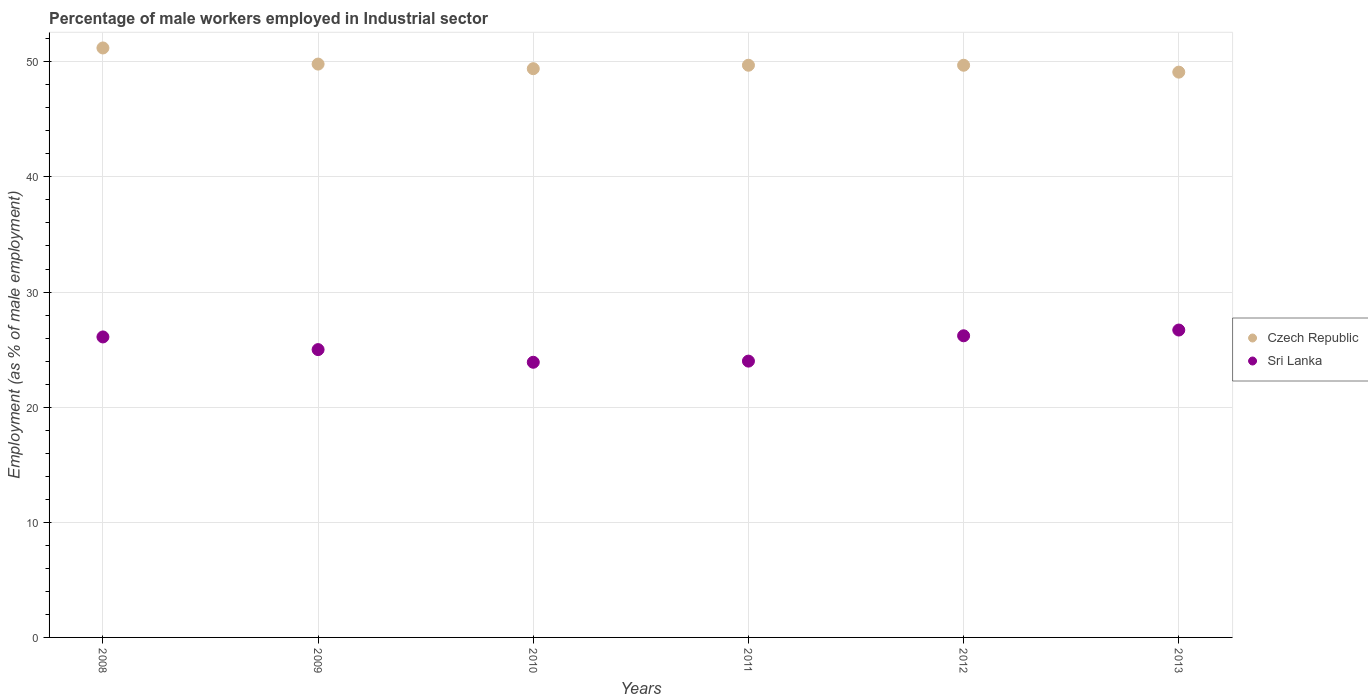What is the percentage of male workers employed in Industrial sector in Czech Republic in 2013?
Provide a short and direct response. 49.1. Across all years, what is the maximum percentage of male workers employed in Industrial sector in Sri Lanka?
Make the answer very short. 26.7. Across all years, what is the minimum percentage of male workers employed in Industrial sector in Czech Republic?
Your answer should be compact. 49.1. In which year was the percentage of male workers employed in Industrial sector in Sri Lanka minimum?
Your answer should be very brief. 2010. What is the total percentage of male workers employed in Industrial sector in Sri Lanka in the graph?
Provide a short and direct response. 151.9. What is the difference between the percentage of male workers employed in Industrial sector in Sri Lanka in 2011 and the percentage of male workers employed in Industrial sector in Czech Republic in 2010?
Your response must be concise. -25.4. What is the average percentage of male workers employed in Industrial sector in Czech Republic per year?
Keep it short and to the point. 49.82. In the year 2012, what is the difference between the percentage of male workers employed in Industrial sector in Sri Lanka and percentage of male workers employed in Industrial sector in Czech Republic?
Keep it short and to the point. -23.5. What is the ratio of the percentage of male workers employed in Industrial sector in Sri Lanka in 2010 to that in 2012?
Provide a succinct answer. 0.91. Is the percentage of male workers employed in Industrial sector in Sri Lanka in 2008 less than that in 2009?
Ensure brevity in your answer.  No. Is the difference between the percentage of male workers employed in Industrial sector in Sri Lanka in 2009 and 2010 greater than the difference between the percentage of male workers employed in Industrial sector in Czech Republic in 2009 and 2010?
Offer a terse response. Yes. What is the difference between the highest and the second highest percentage of male workers employed in Industrial sector in Czech Republic?
Give a very brief answer. 1.4. What is the difference between the highest and the lowest percentage of male workers employed in Industrial sector in Sri Lanka?
Ensure brevity in your answer.  2.8. In how many years, is the percentage of male workers employed in Industrial sector in Czech Republic greater than the average percentage of male workers employed in Industrial sector in Czech Republic taken over all years?
Provide a succinct answer. 1. Is the sum of the percentage of male workers employed in Industrial sector in Czech Republic in 2009 and 2013 greater than the maximum percentage of male workers employed in Industrial sector in Sri Lanka across all years?
Provide a short and direct response. Yes. Does the percentage of male workers employed in Industrial sector in Sri Lanka monotonically increase over the years?
Offer a terse response. No. Is the percentage of male workers employed in Industrial sector in Sri Lanka strictly less than the percentage of male workers employed in Industrial sector in Czech Republic over the years?
Give a very brief answer. Yes. How many dotlines are there?
Keep it short and to the point. 2. How many years are there in the graph?
Offer a very short reply. 6. Are the values on the major ticks of Y-axis written in scientific E-notation?
Make the answer very short. No. Does the graph contain grids?
Provide a short and direct response. Yes. How many legend labels are there?
Your response must be concise. 2. What is the title of the graph?
Provide a succinct answer. Percentage of male workers employed in Industrial sector. Does "Austria" appear as one of the legend labels in the graph?
Provide a succinct answer. No. What is the label or title of the X-axis?
Give a very brief answer. Years. What is the label or title of the Y-axis?
Keep it short and to the point. Employment (as % of male employment). What is the Employment (as % of male employment) of Czech Republic in 2008?
Give a very brief answer. 51.2. What is the Employment (as % of male employment) in Sri Lanka in 2008?
Keep it short and to the point. 26.1. What is the Employment (as % of male employment) of Czech Republic in 2009?
Offer a very short reply. 49.8. What is the Employment (as % of male employment) of Czech Republic in 2010?
Give a very brief answer. 49.4. What is the Employment (as % of male employment) in Sri Lanka in 2010?
Give a very brief answer. 23.9. What is the Employment (as % of male employment) in Czech Republic in 2011?
Your answer should be compact. 49.7. What is the Employment (as % of male employment) of Sri Lanka in 2011?
Give a very brief answer. 24. What is the Employment (as % of male employment) of Czech Republic in 2012?
Provide a succinct answer. 49.7. What is the Employment (as % of male employment) of Sri Lanka in 2012?
Your answer should be very brief. 26.2. What is the Employment (as % of male employment) in Czech Republic in 2013?
Give a very brief answer. 49.1. What is the Employment (as % of male employment) of Sri Lanka in 2013?
Your answer should be very brief. 26.7. Across all years, what is the maximum Employment (as % of male employment) of Czech Republic?
Give a very brief answer. 51.2. Across all years, what is the maximum Employment (as % of male employment) of Sri Lanka?
Provide a short and direct response. 26.7. Across all years, what is the minimum Employment (as % of male employment) in Czech Republic?
Your response must be concise. 49.1. Across all years, what is the minimum Employment (as % of male employment) in Sri Lanka?
Ensure brevity in your answer.  23.9. What is the total Employment (as % of male employment) in Czech Republic in the graph?
Keep it short and to the point. 298.9. What is the total Employment (as % of male employment) in Sri Lanka in the graph?
Keep it short and to the point. 151.9. What is the difference between the Employment (as % of male employment) in Czech Republic in 2008 and that in 2009?
Ensure brevity in your answer.  1.4. What is the difference between the Employment (as % of male employment) of Czech Republic in 2008 and that in 2011?
Your answer should be compact. 1.5. What is the difference between the Employment (as % of male employment) in Sri Lanka in 2008 and that in 2011?
Give a very brief answer. 2.1. What is the difference between the Employment (as % of male employment) in Czech Republic in 2008 and that in 2013?
Provide a short and direct response. 2.1. What is the difference between the Employment (as % of male employment) of Czech Republic in 2009 and that in 2010?
Provide a short and direct response. 0.4. What is the difference between the Employment (as % of male employment) of Sri Lanka in 2009 and that in 2010?
Your answer should be compact. 1.1. What is the difference between the Employment (as % of male employment) of Sri Lanka in 2009 and that in 2011?
Keep it short and to the point. 1. What is the difference between the Employment (as % of male employment) of Czech Republic in 2009 and that in 2012?
Give a very brief answer. 0.1. What is the difference between the Employment (as % of male employment) in Sri Lanka in 2009 and that in 2012?
Make the answer very short. -1.2. What is the difference between the Employment (as % of male employment) of Sri Lanka in 2009 and that in 2013?
Your answer should be compact. -1.7. What is the difference between the Employment (as % of male employment) of Czech Republic in 2010 and that in 2011?
Provide a short and direct response. -0.3. What is the difference between the Employment (as % of male employment) of Czech Republic in 2011 and that in 2012?
Offer a terse response. 0. What is the difference between the Employment (as % of male employment) in Sri Lanka in 2012 and that in 2013?
Ensure brevity in your answer.  -0.5. What is the difference between the Employment (as % of male employment) of Czech Republic in 2008 and the Employment (as % of male employment) of Sri Lanka in 2009?
Provide a short and direct response. 26.2. What is the difference between the Employment (as % of male employment) in Czech Republic in 2008 and the Employment (as % of male employment) in Sri Lanka in 2010?
Your response must be concise. 27.3. What is the difference between the Employment (as % of male employment) of Czech Republic in 2008 and the Employment (as % of male employment) of Sri Lanka in 2011?
Offer a very short reply. 27.2. What is the difference between the Employment (as % of male employment) of Czech Republic in 2008 and the Employment (as % of male employment) of Sri Lanka in 2012?
Offer a very short reply. 25. What is the difference between the Employment (as % of male employment) of Czech Republic in 2009 and the Employment (as % of male employment) of Sri Lanka in 2010?
Give a very brief answer. 25.9. What is the difference between the Employment (as % of male employment) of Czech Republic in 2009 and the Employment (as % of male employment) of Sri Lanka in 2011?
Your response must be concise. 25.8. What is the difference between the Employment (as % of male employment) in Czech Republic in 2009 and the Employment (as % of male employment) in Sri Lanka in 2012?
Your answer should be compact. 23.6. What is the difference between the Employment (as % of male employment) in Czech Republic in 2009 and the Employment (as % of male employment) in Sri Lanka in 2013?
Keep it short and to the point. 23.1. What is the difference between the Employment (as % of male employment) of Czech Republic in 2010 and the Employment (as % of male employment) of Sri Lanka in 2011?
Provide a short and direct response. 25.4. What is the difference between the Employment (as % of male employment) of Czech Republic in 2010 and the Employment (as % of male employment) of Sri Lanka in 2012?
Offer a very short reply. 23.2. What is the difference between the Employment (as % of male employment) in Czech Republic in 2010 and the Employment (as % of male employment) in Sri Lanka in 2013?
Offer a very short reply. 22.7. What is the difference between the Employment (as % of male employment) in Czech Republic in 2011 and the Employment (as % of male employment) in Sri Lanka in 2012?
Provide a short and direct response. 23.5. What is the difference between the Employment (as % of male employment) in Czech Republic in 2011 and the Employment (as % of male employment) in Sri Lanka in 2013?
Provide a succinct answer. 23. What is the difference between the Employment (as % of male employment) in Czech Republic in 2012 and the Employment (as % of male employment) in Sri Lanka in 2013?
Provide a short and direct response. 23. What is the average Employment (as % of male employment) of Czech Republic per year?
Offer a terse response. 49.82. What is the average Employment (as % of male employment) of Sri Lanka per year?
Your response must be concise. 25.32. In the year 2008, what is the difference between the Employment (as % of male employment) in Czech Republic and Employment (as % of male employment) in Sri Lanka?
Offer a very short reply. 25.1. In the year 2009, what is the difference between the Employment (as % of male employment) of Czech Republic and Employment (as % of male employment) of Sri Lanka?
Your answer should be compact. 24.8. In the year 2010, what is the difference between the Employment (as % of male employment) in Czech Republic and Employment (as % of male employment) in Sri Lanka?
Offer a very short reply. 25.5. In the year 2011, what is the difference between the Employment (as % of male employment) of Czech Republic and Employment (as % of male employment) of Sri Lanka?
Provide a short and direct response. 25.7. In the year 2012, what is the difference between the Employment (as % of male employment) of Czech Republic and Employment (as % of male employment) of Sri Lanka?
Your answer should be very brief. 23.5. In the year 2013, what is the difference between the Employment (as % of male employment) of Czech Republic and Employment (as % of male employment) of Sri Lanka?
Make the answer very short. 22.4. What is the ratio of the Employment (as % of male employment) of Czech Republic in 2008 to that in 2009?
Your answer should be very brief. 1.03. What is the ratio of the Employment (as % of male employment) of Sri Lanka in 2008 to that in 2009?
Offer a terse response. 1.04. What is the ratio of the Employment (as % of male employment) in Czech Republic in 2008 to that in 2010?
Provide a short and direct response. 1.04. What is the ratio of the Employment (as % of male employment) of Sri Lanka in 2008 to that in 2010?
Make the answer very short. 1.09. What is the ratio of the Employment (as % of male employment) in Czech Republic in 2008 to that in 2011?
Offer a terse response. 1.03. What is the ratio of the Employment (as % of male employment) of Sri Lanka in 2008 to that in 2011?
Your response must be concise. 1.09. What is the ratio of the Employment (as % of male employment) of Czech Republic in 2008 to that in 2012?
Your response must be concise. 1.03. What is the ratio of the Employment (as % of male employment) of Czech Republic in 2008 to that in 2013?
Your response must be concise. 1.04. What is the ratio of the Employment (as % of male employment) in Sri Lanka in 2008 to that in 2013?
Your answer should be very brief. 0.98. What is the ratio of the Employment (as % of male employment) of Sri Lanka in 2009 to that in 2010?
Give a very brief answer. 1.05. What is the ratio of the Employment (as % of male employment) in Czech Republic in 2009 to that in 2011?
Offer a terse response. 1. What is the ratio of the Employment (as % of male employment) of Sri Lanka in 2009 to that in 2011?
Your response must be concise. 1.04. What is the ratio of the Employment (as % of male employment) in Czech Republic in 2009 to that in 2012?
Keep it short and to the point. 1. What is the ratio of the Employment (as % of male employment) in Sri Lanka in 2009 to that in 2012?
Your response must be concise. 0.95. What is the ratio of the Employment (as % of male employment) of Czech Republic in 2009 to that in 2013?
Offer a very short reply. 1.01. What is the ratio of the Employment (as % of male employment) in Sri Lanka in 2009 to that in 2013?
Ensure brevity in your answer.  0.94. What is the ratio of the Employment (as % of male employment) in Czech Republic in 2010 to that in 2011?
Your answer should be compact. 0.99. What is the ratio of the Employment (as % of male employment) of Sri Lanka in 2010 to that in 2011?
Offer a terse response. 1. What is the ratio of the Employment (as % of male employment) in Czech Republic in 2010 to that in 2012?
Give a very brief answer. 0.99. What is the ratio of the Employment (as % of male employment) of Sri Lanka in 2010 to that in 2012?
Make the answer very short. 0.91. What is the ratio of the Employment (as % of male employment) in Sri Lanka in 2010 to that in 2013?
Your answer should be very brief. 0.9. What is the ratio of the Employment (as % of male employment) of Czech Republic in 2011 to that in 2012?
Your response must be concise. 1. What is the ratio of the Employment (as % of male employment) in Sri Lanka in 2011 to that in 2012?
Make the answer very short. 0.92. What is the ratio of the Employment (as % of male employment) of Czech Republic in 2011 to that in 2013?
Keep it short and to the point. 1.01. What is the ratio of the Employment (as % of male employment) of Sri Lanka in 2011 to that in 2013?
Provide a succinct answer. 0.9. What is the ratio of the Employment (as % of male employment) of Czech Republic in 2012 to that in 2013?
Offer a terse response. 1.01. What is the ratio of the Employment (as % of male employment) in Sri Lanka in 2012 to that in 2013?
Your answer should be very brief. 0.98. What is the difference between the highest and the lowest Employment (as % of male employment) in Czech Republic?
Give a very brief answer. 2.1. What is the difference between the highest and the lowest Employment (as % of male employment) in Sri Lanka?
Give a very brief answer. 2.8. 